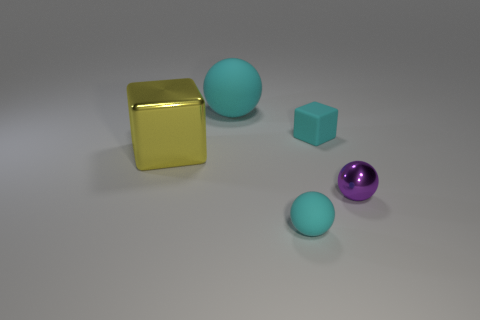Add 1 tiny purple metal balls. How many objects exist? 6 Subtract all balls. How many objects are left? 2 Add 3 big metallic things. How many big metallic things exist? 4 Subtract 0 blue spheres. How many objects are left? 5 Subtract all big matte things. Subtract all tiny metal spheres. How many objects are left? 3 Add 2 tiny cyan matte balls. How many tiny cyan matte balls are left? 3 